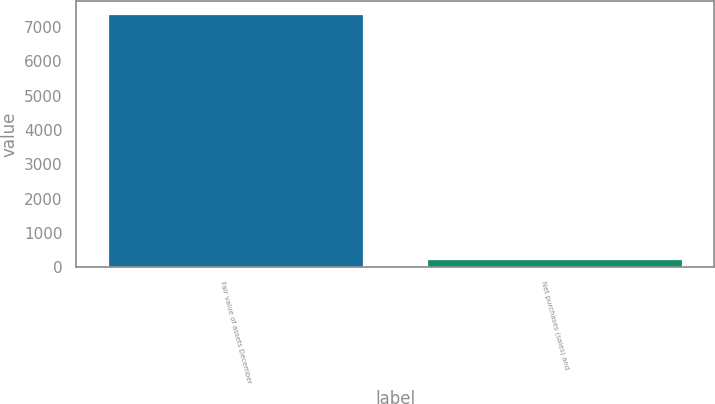<chart> <loc_0><loc_0><loc_500><loc_500><bar_chart><fcel>Fair value of assets December<fcel>Net purchases (sales) and<nl><fcel>7373.4<fcel>248<nl></chart> 